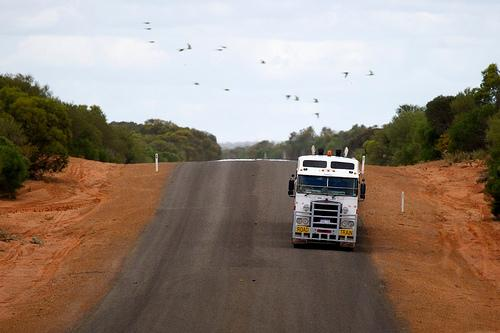Mention the principal subject in the image and its ongoing action. A big white truck is moving along a paved road. Point out the central object in the image and its current activity. A white truck is cruising down a grey asphalt road. Highlight the main focus of the image and the action happening. A white cargo truck is in motion on a grey paved road. Describe the image's focal point and the observed action. A sizable white truck is journeying along a grey roadway. Explain the central theme of the image and the action taking place. A hefty white truck is navigating along a grey pavement. Discuss the primary focal element in the image and what it is doing. A white lorry is transiting over a grey surfaced road. Outline the core subject of the image and the unfolding event. A white truck is progressing on a grey, paved street. State the key subject in the image and its happening action. A large white truck is rolling down a grey tarmac road. Identify the primary object in the image and its activity. A large white truck is traveling down a paved grey road. Comment on the main object in the image and its in-progress action. A white truck is traversing through a grey surfaced lane. 